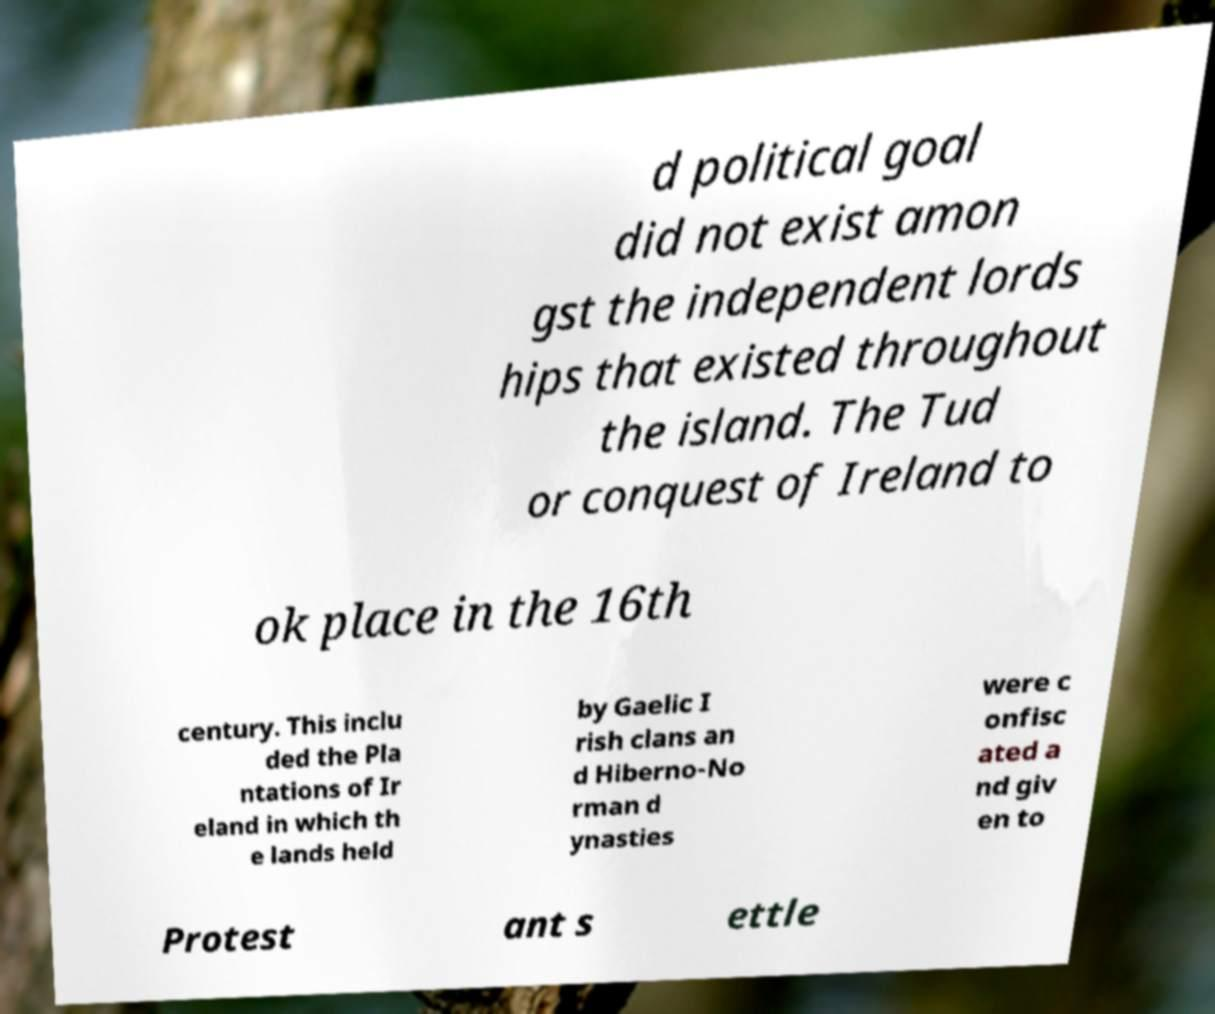For documentation purposes, I need the text within this image transcribed. Could you provide that? d political goal did not exist amon gst the independent lords hips that existed throughout the island. The Tud or conquest of Ireland to ok place in the 16th century. This inclu ded the Pla ntations of Ir eland in which th e lands held by Gaelic I rish clans an d Hiberno-No rman d ynasties were c onfisc ated a nd giv en to Protest ant s ettle 